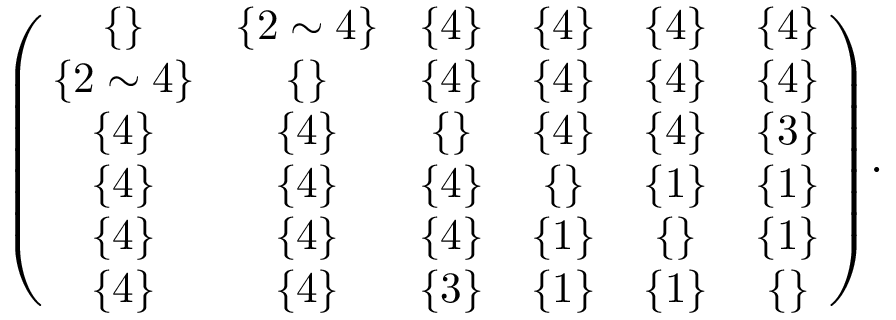Convert formula to latex. <formula><loc_0><loc_0><loc_500><loc_500>\begin{array} { r } { \left ( \, \begin{array} { c c c c c c } { \{ \} } & { \, \{ 2 \sim 4 \} \, } & { \{ 4 \} } & { \{ 4 \} } & { \{ 4 \} } & { \{ 4 \} } \\ { \{ 2 \sim 4 \} } & { \{ \} } & { \{ 4 \} } & { \{ 4 \} } & { \{ 4 \} } & { \{ 4 \} } \\ { \{ 4 \} } & { \{ 4 \} } & { \{ \} } & { \{ 4 \} } & { \{ 4 \} } & { \{ 3 \} } \\ { \{ 4 \} } & { \{ 4 \} } & { \{ 4 \} } & { \{ \} } & { \{ 1 \} } & { \{ 1 \} } \\ { \{ 4 \} } & { \{ 4 \} } & { \{ 4 \} } & { \{ 1 \} } & { \{ \} } & { \{ 1 \} } \\ { \{ 4 \} } & { \{ 4 \} } & { \{ 3 \} } & { \{ 1 \} } & { \{ 1 \} } & { \{ \} } \end{array} \, \right ) \, . } \end{array}</formula> 